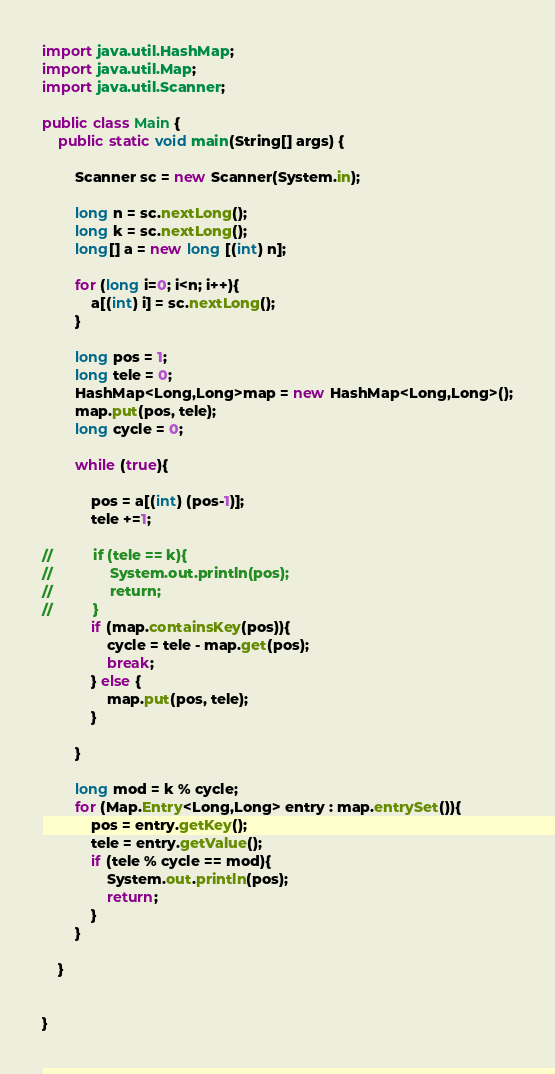Convert code to text. <code><loc_0><loc_0><loc_500><loc_500><_Java_>import java.util.HashMap;
import java.util.Map;
import java.util.Scanner;

public class Main {
	public static void main(String[] args) {

		Scanner sc = new Scanner(System.in);

		long n = sc.nextLong();
		long k = sc.nextLong();
		long[] a = new long [(int) n];

		for (long i=0; i<n; i++){
			a[(int) i] = sc.nextLong();
		}

		long pos = 1;
		long tele = 0;
		HashMap<Long,Long>map = new HashMap<Long,Long>();
		map.put(pos, tele);
		long cycle = 0;

		while (true){

			pos = a[(int) (pos-1)];
			tele +=1;

//			if (tele == k){
//				System.out.println(pos);
//				return;
//			}
			if (map.containsKey(pos)){
				cycle = tele - map.get(pos);
				break;
			} else {
				map.put(pos, tele);
			}

		}

		long mod = k % cycle;
		for (Map.Entry<Long,Long> entry : map.entrySet()){
			pos = entry.getKey();
			tele = entry.getValue();
			if (tele % cycle == mod){
				System.out.println(pos);
				return;
			}
		}

	}


}</code> 